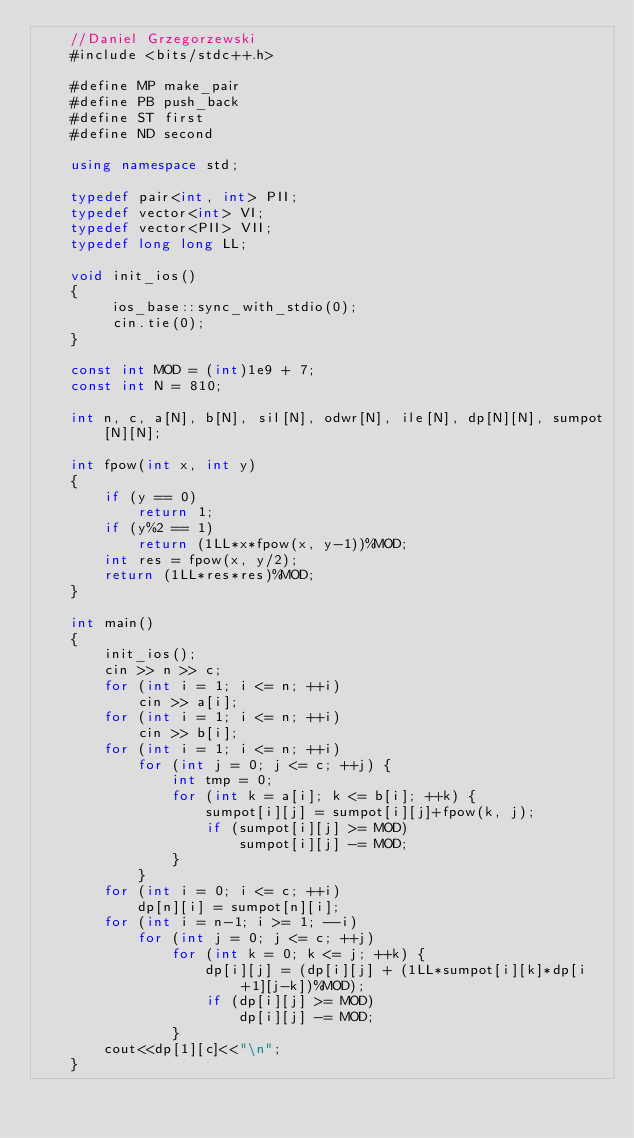Convert code to text. <code><loc_0><loc_0><loc_500><loc_500><_C++_>    //Daniel Grzegorzewski
    #include <bits/stdc++.h>
     
    #define MP make_pair
    #define PB push_back
    #define ST first
    #define ND second
     
    using namespace std;
     
    typedef pair<int, int> PII;
    typedef vector<int> VI;
    typedef vector<PII> VII;
    typedef long long LL;
     
    void init_ios()
    {
         ios_base::sync_with_stdio(0);
         cin.tie(0);
    }
     
    const int MOD = (int)1e9 + 7;
    const int N = 810;
     
    int n, c, a[N], b[N], sil[N], odwr[N], ile[N], dp[N][N], sumpot[N][N];
     
    int fpow(int x, int y)
    {
    	if (y == 0)
    		return 1;
    	if (y%2 == 1)
    		return (1LL*x*fpow(x, y-1))%MOD;
    	int res = fpow(x, y/2);
    	return (1LL*res*res)%MOD;
    }
     
    int main()
    {
        init_ios();
        cin >> n >> c;
        for (int i = 1; i <= n; ++i)
        	cin >> a[i];
        for (int i = 1; i <= n; ++i)
        	cin >> b[i];
        for (int i = 1; i <= n; ++i)
        	for (int j = 0; j <= c; ++j) {
        		int tmp = 0;
        		for (int k = a[i]; k <= b[i]; ++k) {
        			sumpot[i][j] = sumpot[i][j]+fpow(k, j);
        			if (sumpot[i][j] >= MOD)
        				sumpot[i][j] -= MOD;
        		}
        	}
        for (int i = 0; i <= c; ++i)
        	dp[n][i] = sumpot[n][i];
        for (int i = n-1; i >= 1; --i)
        	for (int j = 0; j <= c; ++j)
        		for (int k = 0; k <= j; ++k) {
        			dp[i][j] = (dp[i][j] + (1LL*sumpot[i][k]*dp[i+1][j-k])%MOD);
        			if (dp[i][j] >= MOD)
        				dp[i][j] -= MOD;
        		}
        cout<<dp[1][c]<<"\n";
    }</code> 